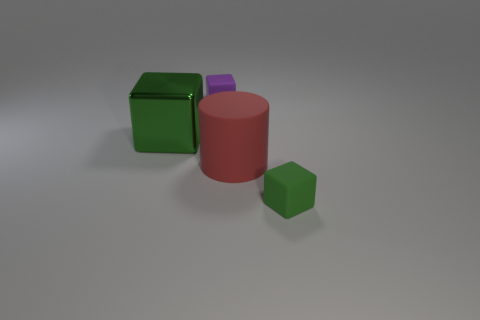Subtract all matte blocks. How many blocks are left? 1 Add 1 large metallic objects. How many objects exist? 5 Subtract all purple cubes. How many cubes are left? 2 Subtract 1 cylinders. How many cylinders are left? 0 Add 2 small matte objects. How many small matte objects are left? 4 Add 4 green objects. How many green objects exist? 6 Subtract 1 purple blocks. How many objects are left? 3 Subtract all cylinders. How many objects are left? 3 Subtract all purple cylinders. Subtract all purple cubes. How many cylinders are left? 1 Subtract all brown blocks. How many cyan cylinders are left? 0 